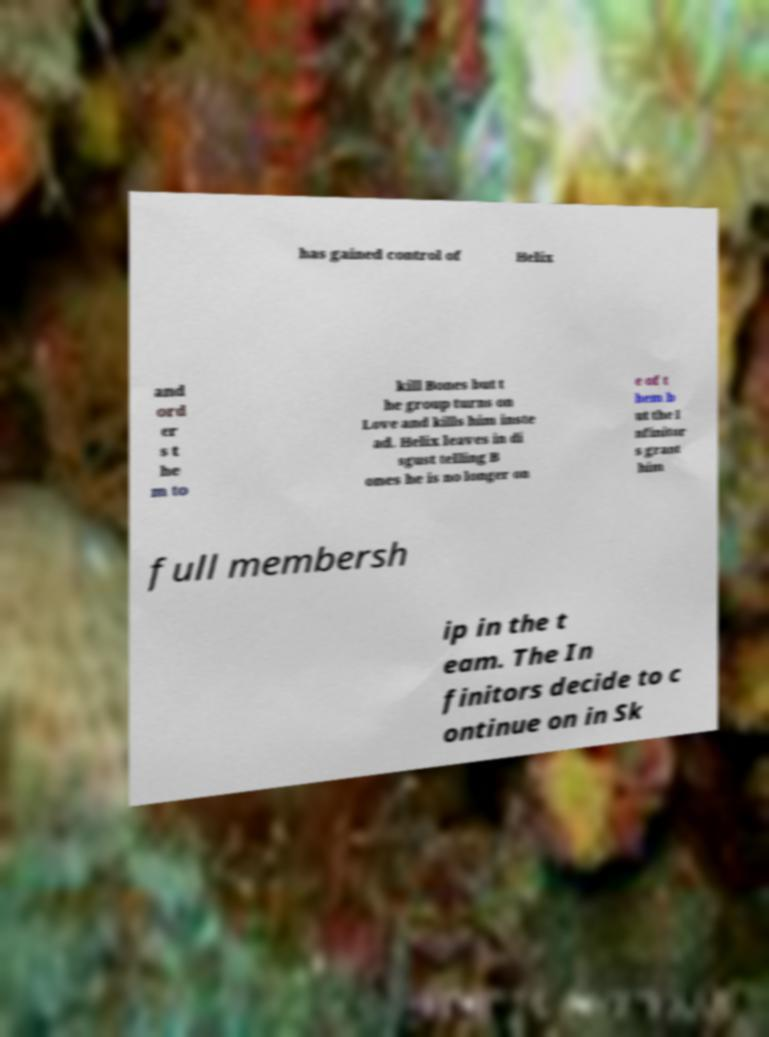Could you assist in decoding the text presented in this image and type it out clearly? has gained control of Helix and ord er s t he m to kill Bones but t he group turns on Love and kills him inste ad. Helix leaves in di sgust telling B ones he is no longer on e of t hem b ut the I nfinitor s grant him full membersh ip in the t eam. The In finitors decide to c ontinue on in Sk 